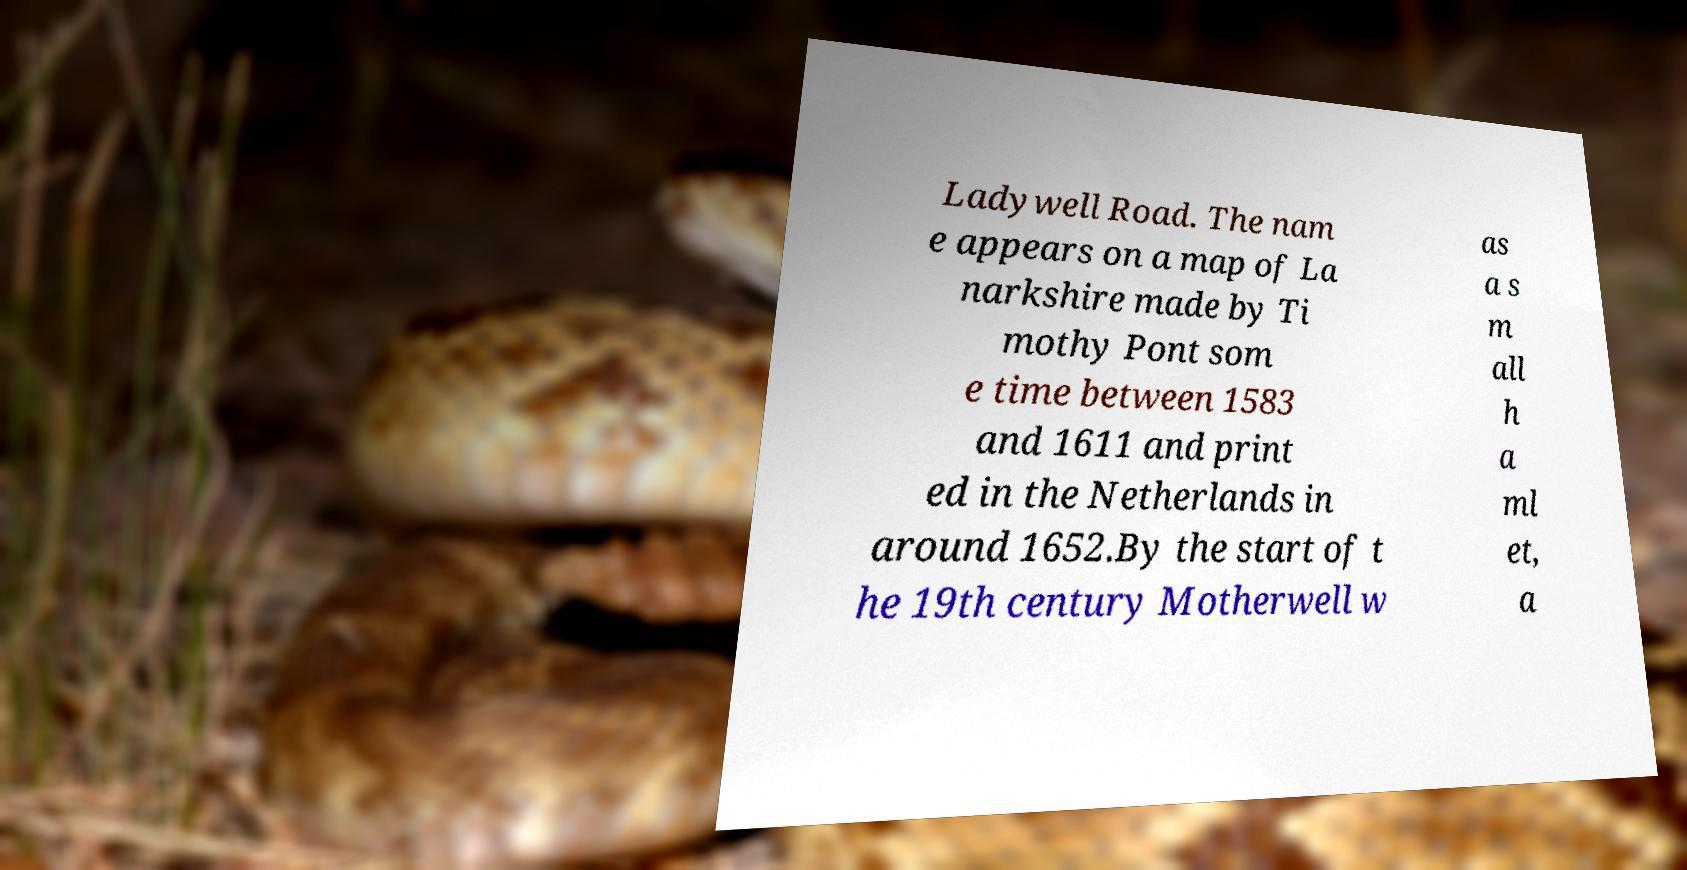I need the written content from this picture converted into text. Can you do that? Ladywell Road. The nam e appears on a map of La narkshire made by Ti mothy Pont som e time between 1583 and 1611 and print ed in the Netherlands in around 1652.By the start of t he 19th century Motherwell w as a s m all h a ml et, a 